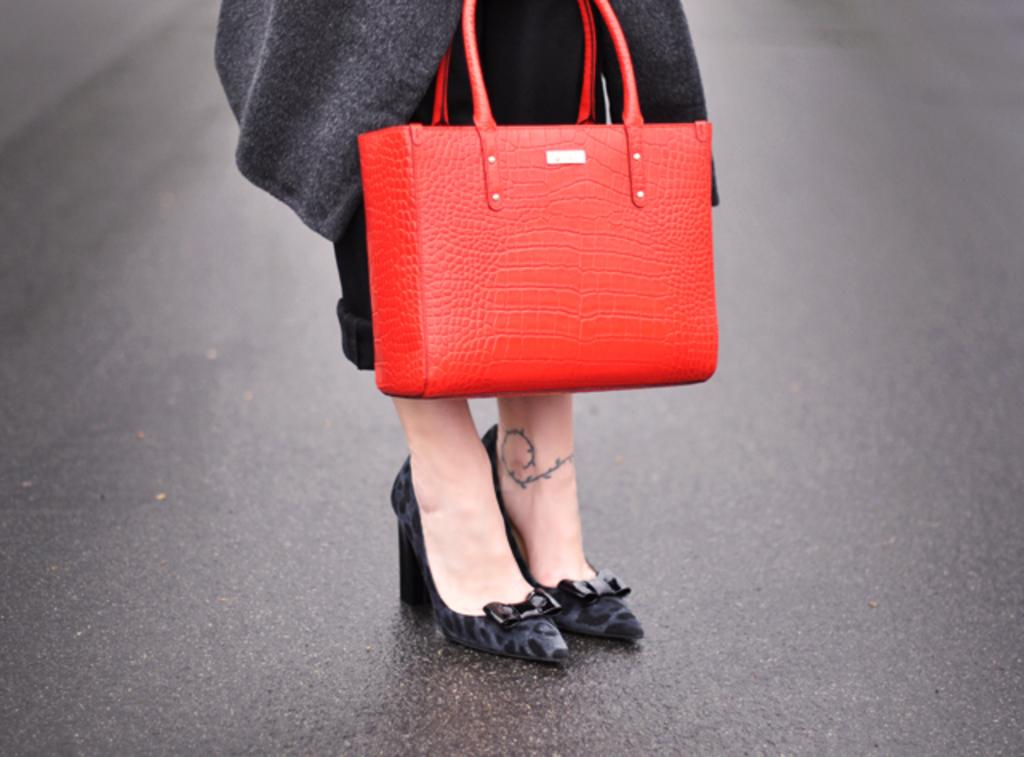Who or what is present in the image? There is a person in the image. What is the person wearing on their feet? The person is wearing shoes. What color is the bag that is visible in the image? The bag is red. Where is the person standing in the image? The person is standing on a road. What type of lip can be seen on the cushion in the image? There is no lip or cushion present in the image. Where is the lunchroom located in the image? There is no lunchroom present in the image. 